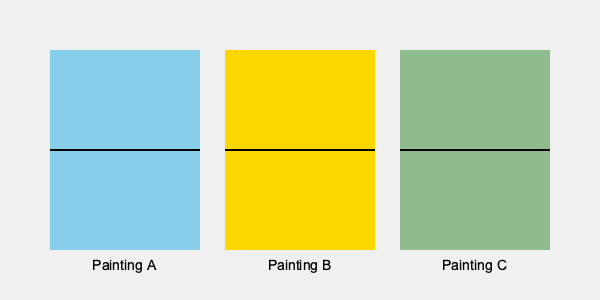Analyze the color palettes of the three Impressionist landscapes shown above. Which painting is most likely to depict a sunny wheat field, and what brushwork technique would you expect to see in such a painting? To answer this question, we need to consider the color palettes and typical Impressionist techniques:

1. Color analysis:
   - Painting A: Predominantly light blue, suggesting sky or water
   - Painting B: Predominantly yellow, suggesting sunlight or wheat
   - Painting C: Predominantly green, suggesting grass or trees

2. Subject matter:
   A sunny wheat field would typically be represented by warm, golden hues, which are most prominent in Painting B.

3. Impressionist techniques:
   Impressionists often used:
   - Short, broken brushstrokes
   - Pure, unmixed colors
   - Emphasis on light and its changing qualities

4. Brushwork for a wheat field:
   To capture the essence of a sunny wheat field, an Impressionist painter would likely use:
   - Short, parallel brushstrokes to represent individual stalks of wheat
   - Dabs of pure yellow, orange, and occasional complementary purple for shadows
   - Loose, textured application to create a sense of movement and light

5. Conclusion:
   Painting B, with its dominant yellow palette, is most likely to depict a sunny wheat field. The expected brushwork would be short, parallel strokes in pure yellows and complementary colors to capture the light and texture of the wheat.
Answer: Painting B; short, parallel brushstrokes in pure yellows and complementary colors 